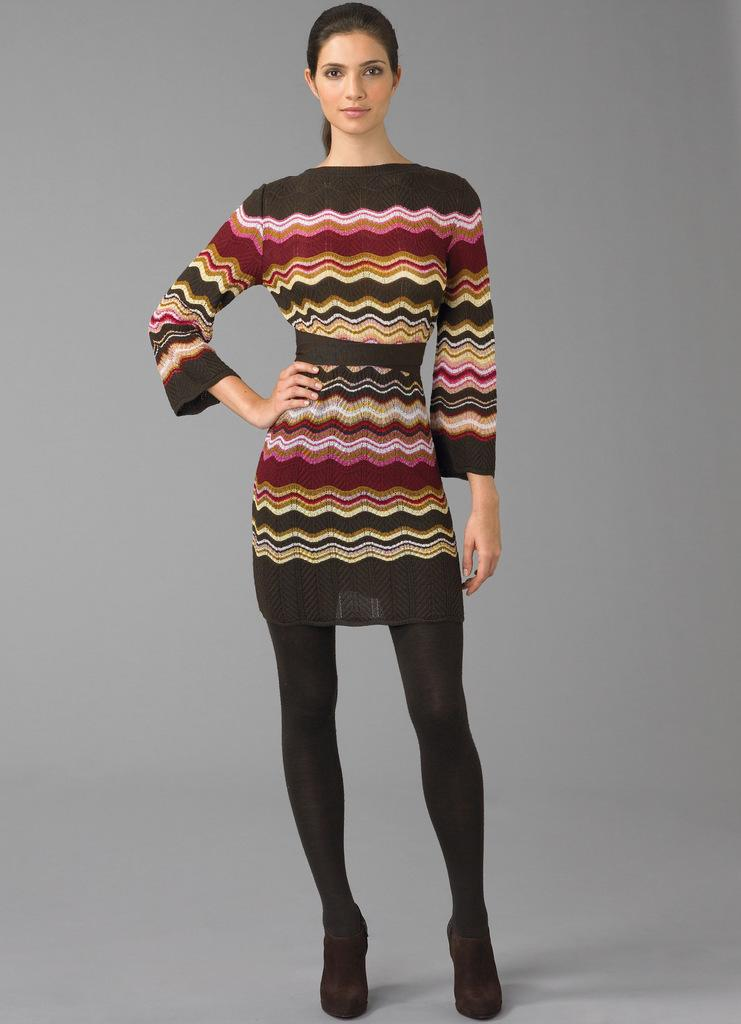What is the main subject of the image? There is a woman standing in the image. Can you describe the background of the image? The background of the image is grey in color. What type of hose is the woman holding in the image? There is no hose present in the image; the woman is standing without any visible objects. How many fingers can be seen on the woman's hand in the image? The image does not show the woman's hand or any fingers, so it cannot be determined from the image. 